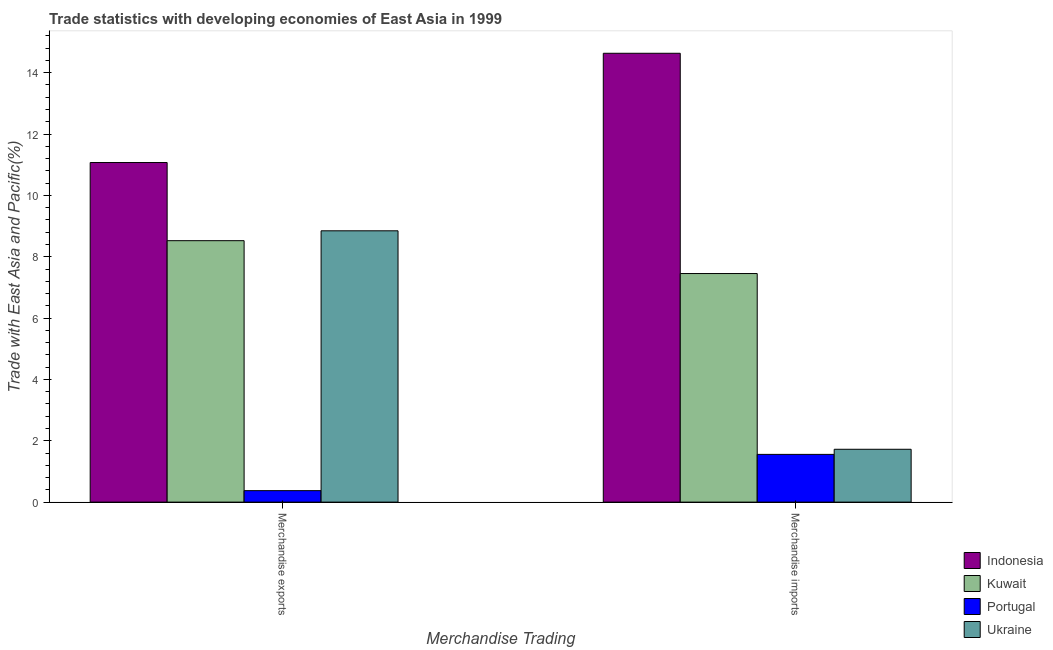How many groups of bars are there?
Your answer should be compact. 2. Are the number of bars per tick equal to the number of legend labels?
Ensure brevity in your answer.  Yes. How many bars are there on the 2nd tick from the right?
Ensure brevity in your answer.  4. What is the merchandise exports in Ukraine?
Offer a very short reply. 8.85. Across all countries, what is the maximum merchandise imports?
Provide a short and direct response. 14.63. Across all countries, what is the minimum merchandise exports?
Your answer should be compact. 0.37. In which country was the merchandise imports maximum?
Your answer should be compact. Indonesia. In which country was the merchandise exports minimum?
Offer a very short reply. Portugal. What is the total merchandise imports in the graph?
Provide a succinct answer. 25.37. What is the difference between the merchandise imports in Kuwait and that in Indonesia?
Your response must be concise. -7.18. What is the difference between the merchandise imports in Ukraine and the merchandise exports in Portugal?
Keep it short and to the point. 1.35. What is the average merchandise exports per country?
Ensure brevity in your answer.  7.2. What is the difference between the merchandise imports and merchandise exports in Ukraine?
Offer a terse response. -7.12. What is the ratio of the merchandise exports in Kuwait to that in Portugal?
Provide a succinct answer. 22.78. Is the merchandise imports in Indonesia less than that in Portugal?
Your answer should be compact. No. What does the 2nd bar from the left in Merchandise exports represents?
Offer a very short reply. Kuwait. What does the 3rd bar from the right in Merchandise exports represents?
Your answer should be compact. Kuwait. How many bars are there?
Your response must be concise. 8. What is the difference between two consecutive major ticks on the Y-axis?
Your answer should be very brief. 2. Does the graph contain grids?
Offer a terse response. No. Where does the legend appear in the graph?
Your answer should be compact. Bottom right. How many legend labels are there?
Make the answer very short. 4. What is the title of the graph?
Ensure brevity in your answer.  Trade statistics with developing economies of East Asia in 1999. What is the label or title of the X-axis?
Offer a very short reply. Merchandise Trading. What is the label or title of the Y-axis?
Offer a terse response. Trade with East Asia and Pacific(%). What is the Trade with East Asia and Pacific(%) of Indonesia in Merchandise exports?
Provide a succinct answer. 11.07. What is the Trade with East Asia and Pacific(%) in Kuwait in Merchandise exports?
Your answer should be compact. 8.52. What is the Trade with East Asia and Pacific(%) in Portugal in Merchandise exports?
Your response must be concise. 0.37. What is the Trade with East Asia and Pacific(%) in Ukraine in Merchandise exports?
Make the answer very short. 8.85. What is the Trade with East Asia and Pacific(%) in Indonesia in Merchandise imports?
Give a very brief answer. 14.63. What is the Trade with East Asia and Pacific(%) of Kuwait in Merchandise imports?
Ensure brevity in your answer.  7.45. What is the Trade with East Asia and Pacific(%) of Portugal in Merchandise imports?
Offer a terse response. 1.56. What is the Trade with East Asia and Pacific(%) in Ukraine in Merchandise imports?
Your answer should be very brief. 1.72. Across all Merchandise Trading, what is the maximum Trade with East Asia and Pacific(%) of Indonesia?
Offer a terse response. 14.63. Across all Merchandise Trading, what is the maximum Trade with East Asia and Pacific(%) of Kuwait?
Offer a very short reply. 8.52. Across all Merchandise Trading, what is the maximum Trade with East Asia and Pacific(%) in Portugal?
Your answer should be very brief. 1.56. Across all Merchandise Trading, what is the maximum Trade with East Asia and Pacific(%) in Ukraine?
Your response must be concise. 8.85. Across all Merchandise Trading, what is the minimum Trade with East Asia and Pacific(%) in Indonesia?
Ensure brevity in your answer.  11.07. Across all Merchandise Trading, what is the minimum Trade with East Asia and Pacific(%) of Kuwait?
Ensure brevity in your answer.  7.45. Across all Merchandise Trading, what is the minimum Trade with East Asia and Pacific(%) of Portugal?
Offer a very short reply. 0.37. Across all Merchandise Trading, what is the minimum Trade with East Asia and Pacific(%) of Ukraine?
Make the answer very short. 1.72. What is the total Trade with East Asia and Pacific(%) in Indonesia in the graph?
Provide a short and direct response. 25.71. What is the total Trade with East Asia and Pacific(%) in Kuwait in the graph?
Make the answer very short. 15.98. What is the total Trade with East Asia and Pacific(%) of Portugal in the graph?
Make the answer very short. 1.93. What is the total Trade with East Asia and Pacific(%) in Ukraine in the graph?
Your response must be concise. 10.57. What is the difference between the Trade with East Asia and Pacific(%) in Indonesia in Merchandise exports and that in Merchandise imports?
Provide a succinct answer. -3.56. What is the difference between the Trade with East Asia and Pacific(%) in Kuwait in Merchandise exports and that in Merchandise imports?
Your response must be concise. 1.07. What is the difference between the Trade with East Asia and Pacific(%) in Portugal in Merchandise exports and that in Merchandise imports?
Your response must be concise. -1.18. What is the difference between the Trade with East Asia and Pacific(%) of Ukraine in Merchandise exports and that in Merchandise imports?
Offer a terse response. 7.12. What is the difference between the Trade with East Asia and Pacific(%) of Indonesia in Merchandise exports and the Trade with East Asia and Pacific(%) of Kuwait in Merchandise imports?
Your response must be concise. 3.62. What is the difference between the Trade with East Asia and Pacific(%) in Indonesia in Merchandise exports and the Trade with East Asia and Pacific(%) in Portugal in Merchandise imports?
Keep it short and to the point. 9.52. What is the difference between the Trade with East Asia and Pacific(%) in Indonesia in Merchandise exports and the Trade with East Asia and Pacific(%) in Ukraine in Merchandise imports?
Give a very brief answer. 9.35. What is the difference between the Trade with East Asia and Pacific(%) of Kuwait in Merchandise exports and the Trade with East Asia and Pacific(%) of Portugal in Merchandise imports?
Ensure brevity in your answer.  6.97. What is the difference between the Trade with East Asia and Pacific(%) of Kuwait in Merchandise exports and the Trade with East Asia and Pacific(%) of Ukraine in Merchandise imports?
Keep it short and to the point. 6.8. What is the difference between the Trade with East Asia and Pacific(%) of Portugal in Merchandise exports and the Trade with East Asia and Pacific(%) of Ukraine in Merchandise imports?
Offer a terse response. -1.35. What is the average Trade with East Asia and Pacific(%) in Indonesia per Merchandise Trading?
Make the answer very short. 12.85. What is the average Trade with East Asia and Pacific(%) in Kuwait per Merchandise Trading?
Provide a short and direct response. 7.99. What is the average Trade with East Asia and Pacific(%) of Portugal per Merchandise Trading?
Provide a succinct answer. 0.97. What is the average Trade with East Asia and Pacific(%) of Ukraine per Merchandise Trading?
Your answer should be compact. 5.28. What is the difference between the Trade with East Asia and Pacific(%) in Indonesia and Trade with East Asia and Pacific(%) in Kuwait in Merchandise exports?
Your response must be concise. 2.55. What is the difference between the Trade with East Asia and Pacific(%) in Indonesia and Trade with East Asia and Pacific(%) in Portugal in Merchandise exports?
Your answer should be very brief. 10.7. What is the difference between the Trade with East Asia and Pacific(%) in Indonesia and Trade with East Asia and Pacific(%) in Ukraine in Merchandise exports?
Your answer should be very brief. 2.23. What is the difference between the Trade with East Asia and Pacific(%) of Kuwait and Trade with East Asia and Pacific(%) of Portugal in Merchandise exports?
Provide a succinct answer. 8.15. What is the difference between the Trade with East Asia and Pacific(%) in Kuwait and Trade with East Asia and Pacific(%) in Ukraine in Merchandise exports?
Make the answer very short. -0.32. What is the difference between the Trade with East Asia and Pacific(%) of Portugal and Trade with East Asia and Pacific(%) of Ukraine in Merchandise exports?
Offer a terse response. -8.47. What is the difference between the Trade with East Asia and Pacific(%) of Indonesia and Trade with East Asia and Pacific(%) of Kuwait in Merchandise imports?
Your answer should be compact. 7.18. What is the difference between the Trade with East Asia and Pacific(%) of Indonesia and Trade with East Asia and Pacific(%) of Portugal in Merchandise imports?
Provide a succinct answer. 13.08. What is the difference between the Trade with East Asia and Pacific(%) of Indonesia and Trade with East Asia and Pacific(%) of Ukraine in Merchandise imports?
Offer a terse response. 12.91. What is the difference between the Trade with East Asia and Pacific(%) in Kuwait and Trade with East Asia and Pacific(%) in Portugal in Merchandise imports?
Keep it short and to the point. 5.9. What is the difference between the Trade with East Asia and Pacific(%) in Kuwait and Trade with East Asia and Pacific(%) in Ukraine in Merchandise imports?
Provide a succinct answer. 5.73. What is the difference between the Trade with East Asia and Pacific(%) of Portugal and Trade with East Asia and Pacific(%) of Ukraine in Merchandise imports?
Offer a terse response. -0.17. What is the ratio of the Trade with East Asia and Pacific(%) of Indonesia in Merchandise exports to that in Merchandise imports?
Your answer should be compact. 0.76. What is the ratio of the Trade with East Asia and Pacific(%) in Kuwait in Merchandise exports to that in Merchandise imports?
Offer a very short reply. 1.14. What is the ratio of the Trade with East Asia and Pacific(%) of Portugal in Merchandise exports to that in Merchandise imports?
Provide a succinct answer. 0.24. What is the ratio of the Trade with East Asia and Pacific(%) in Ukraine in Merchandise exports to that in Merchandise imports?
Keep it short and to the point. 5.13. What is the difference between the highest and the second highest Trade with East Asia and Pacific(%) in Indonesia?
Keep it short and to the point. 3.56. What is the difference between the highest and the second highest Trade with East Asia and Pacific(%) of Kuwait?
Keep it short and to the point. 1.07. What is the difference between the highest and the second highest Trade with East Asia and Pacific(%) in Portugal?
Offer a terse response. 1.18. What is the difference between the highest and the second highest Trade with East Asia and Pacific(%) in Ukraine?
Keep it short and to the point. 7.12. What is the difference between the highest and the lowest Trade with East Asia and Pacific(%) in Indonesia?
Give a very brief answer. 3.56. What is the difference between the highest and the lowest Trade with East Asia and Pacific(%) of Kuwait?
Offer a very short reply. 1.07. What is the difference between the highest and the lowest Trade with East Asia and Pacific(%) of Portugal?
Your answer should be compact. 1.18. What is the difference between the highest and the lowest Trade with East Asia and Pacific(%) in Ukraine?
Your response must be concise. 7.12. 